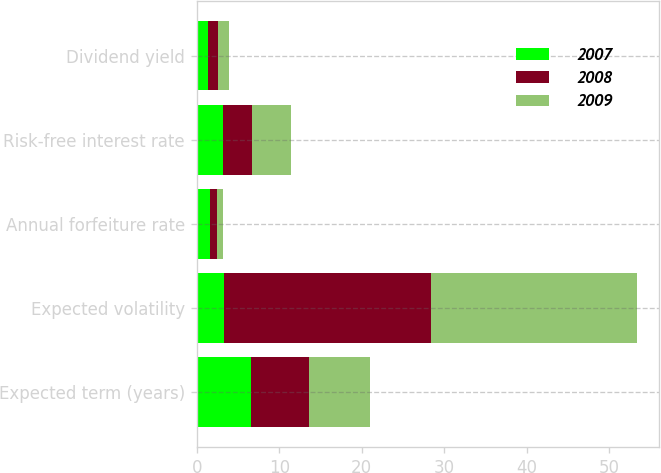Convert chart. <chart><loc_0><loc_0><loc_500><loc_500><stacked_bar_chart><ecel><fcel>Expected term (years)<fcel>Expected volatility<fcel>Annual forfeiture rate<fcel>Risk-free interest rate<fcel>Dividend yield<nl><fcel>2007<fcel>6.6<fcel>3.35<fcel>1.6<fcel>3.2<fcel>1.3<nl><fcel>2008<fcel>7<fcel>25<fcel>0.8<fcel>3.5<fcel>1.3<nl><fcel>2009<fcel>7.4<fcel>25<fcel>0.8<fcel>4.7<fcel>1.3<nl></chart> 